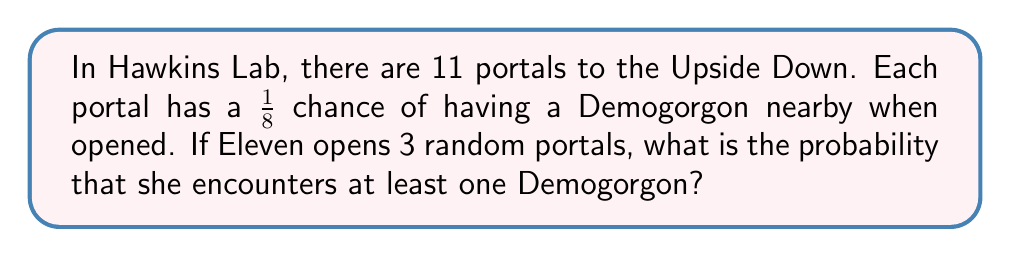Teach me how to tackle this problem. Let's approach this step-by-step:

1) First, let's calculate the probability of not encountering a Demogorgon at a single portal:
   $P(\text{no Demogorgon}) = 1 - \frac{1}{8} = \frac{7}{8}$

2) For Eleven to not encounter any Demogorgons, she must not encounter one at all three portals. The probability of this is:
   $P(\text{no Demogorgons in 3 portals}) = (\frac{7}{8})^3 = \frac{343}{512}$

3) Therefore, the probability of encountering at least one Demogorgon is the complement of this probability:
   $P(\text{at least one Demogorgon}) = 1 - P(\text{no Demogorgons in 3 portals})$

4) Let's calculate this:
   $P(\text{at least one Demogorgon}) = 1 - \frac{343}{512} = \frac{512-343}{512} = \frac{169}{512}$

5) This can be simplified by dividing both numerator and denominator by 169:
   $\frac{169}{512} = \frac{1}{3.0295...} \approx 0.3301$

So, the probability is $\frac{169}{512}$ or approximately 33.01%.
Answer: $\frac{169}{512}$ 